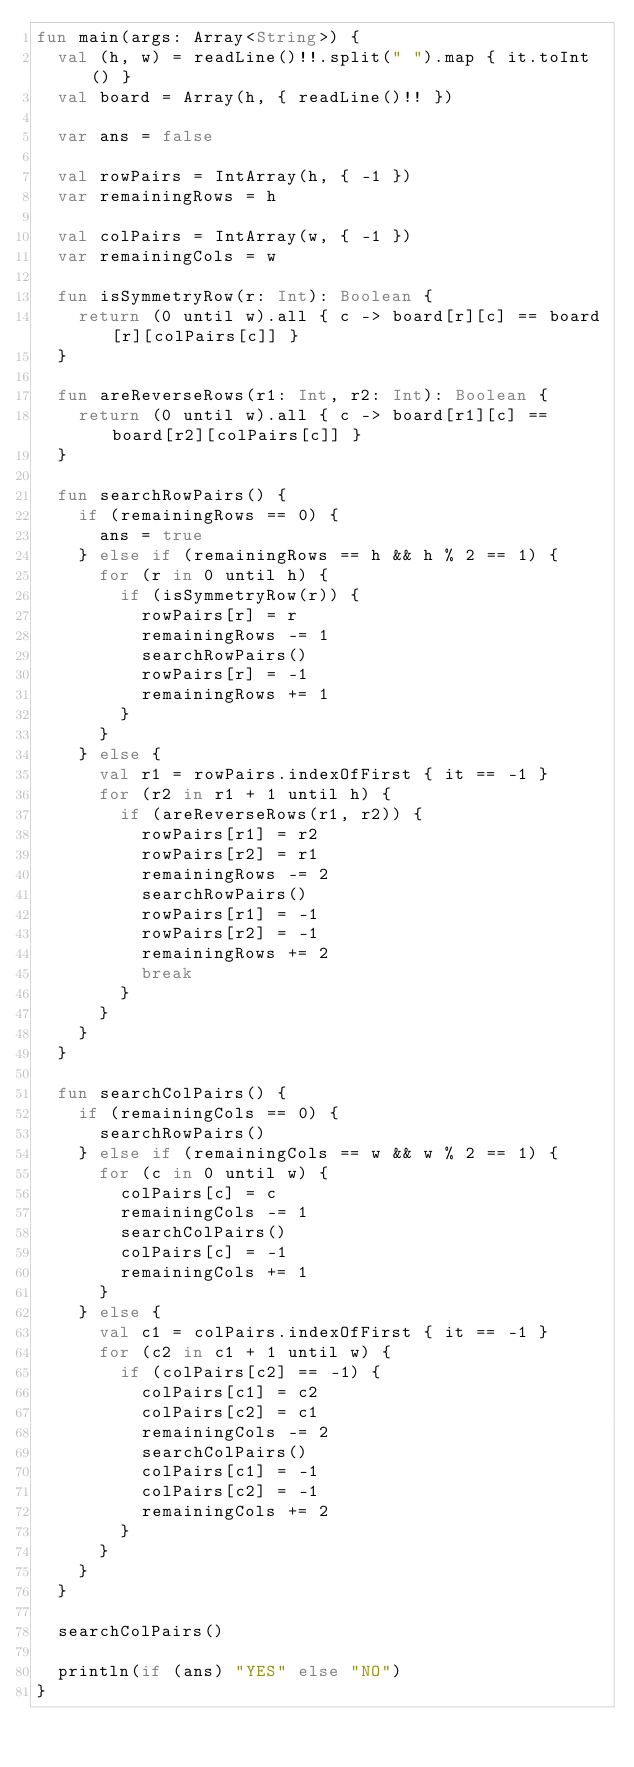<code> <loc_0><loc_0><loc_500><loc_500><_Kotlin_>fun main(args: Array<String>) {
  val (h, w) = readLine()!!.split(" ").map { it.toInt() }
  val board = Array(h, { readLine()!! })

  var ans = false

  val rowPairs = IntArray(h, { -1 })
  var remainingRows = h

  val colPairs = IntArray(w, { -1 })
  var remainingCols = w

  fun isSymmetryRow(r: Int): Boolean {
    return (0 until w).all { c -> board[r][c] == board[r][colPairs[c]] }
  }

  fun areReverseRows(r1: Int, r2: Int): Boolean {
    return (0 until w).all { c -> board[r1][c] == board[r2][colPairs[c]] }
  }

  fun searchRowPairs() {
    if (remainingRows == 0) {
      ans = true
    } else if (remainingRows == h && h % 2 == 1) {
      for (r in 0 until h) {
        if (isSymmetryRow(r)) {
          rowPairs[r] = r
          remainingRows -= 1
          searchRowPairs()
          rowPairs[r] = -1
          remainingRows += 1
        }
      }
    } else {
      val r1 = rowPairs.indexOfFirst { it == -1 }
      for (r2 in r1 + 1 until h) {
        if (areReverseRows(r1, r2)) {
          rowPairs[r1] = r2
          rowPairs[r2] = r1
          remainingRows -= 2
          searchRowPairs()
          rowPairs[r1] = -1
          rowPairs[r2] = -1
          remainingRows += 2
          break
        }
      }
    }
  }

  fun searchColPairs() {
    if (remainingCols == 0) {
      searchRowPairs()
    } else if (remainingCols == w && w % 2 == 1) {
      for (c in 0 until w) {
        colPairs[c] = c
        remainingCols -= 1
        searchColPairs()
        colPairs[c] = -1
        remainingCols += 1
      }
    } else {
      val c1 = colPairs.indexOfFirst { it == -1 }
      for (c2 in c1 + 1 until w) {
        if (colPairs[c2] == -1) {
          colPairs[c1] = c2
          colPairs[c2] = c1
          remainingCols -= 2
          searchColPairs()
          colPairs[c1] = -1
          colPairs[c2] = -1
          remainingCols += 2
        }
      }
    }
  }

  searchColPairs()

  println(if (ans) "YES" else "NO")
}
</code> 